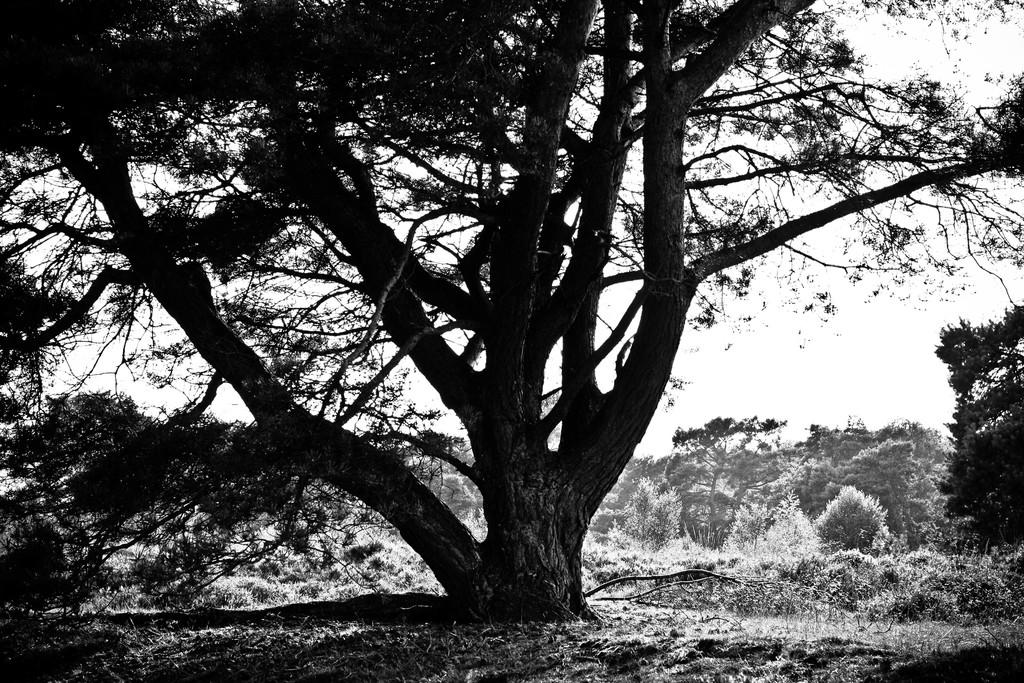What is the color scheme of the image? The image is black and white. What type of vegetation can be seen in the image? There are trees and grass in the image. What part of the natural environment is visible in the background of the image? The sky is visible in the background of the image. Who is the owner of the stitch in the image? There is no stitch present in the image, so it is not possible to determine an owner. 